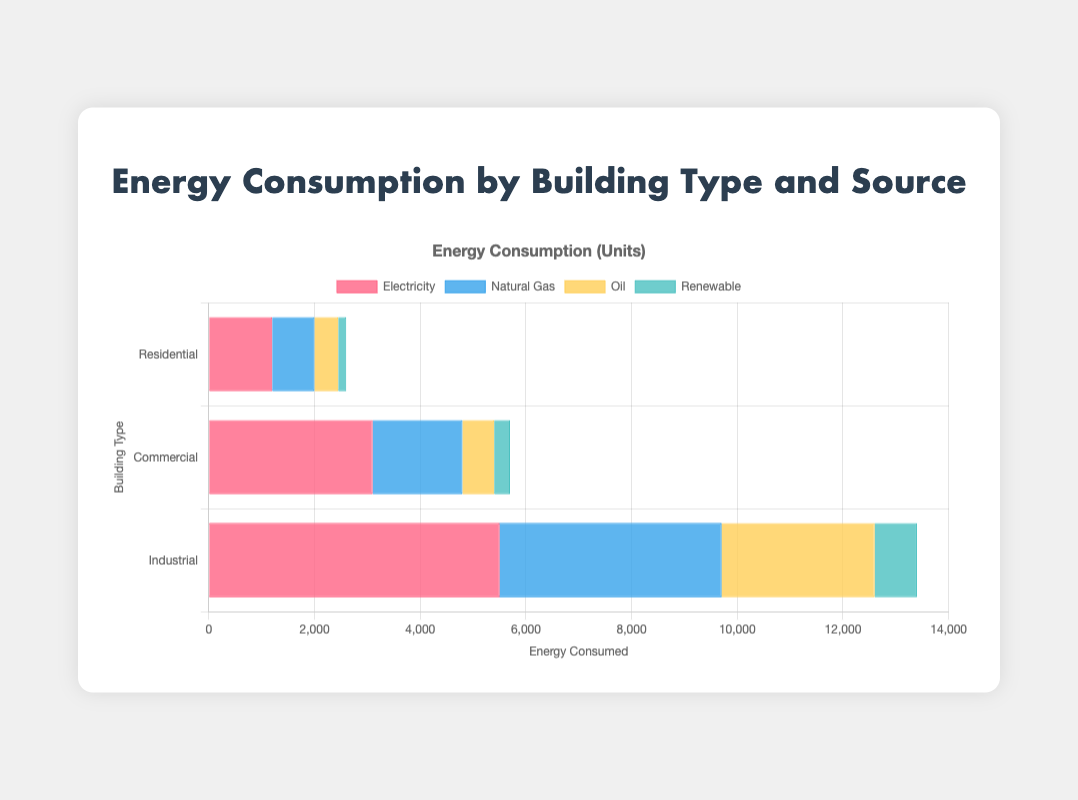Which building type consumes the most electricity? The Industrial building type has the tallest bar for electricity, indicating it consumes the most electricity.
Answer: Industrial Which source of energy contributes the least to the energy consumption of Residential buildings? The bar for Renewable energy in the Residential category is the shortest, indicating it contributes the least.
Answer: Renewable How much more electricity does the Commercial sector consume compared to the Residential sector? The Commercial sector consumes 3100 units of electricity, and the Residential sector consumes 1200 units. The difference is 3100 - 1200.
Answer: 1900 What is the total energy consumption for Natural Gas across all building types? Sum the energy consumption of Natural Gas for all building types: 800 (Residential) + 1700 (Commercial) + 4200 (Industrial) = 6700 units.
Answer: 6700 Compare the energy consumption of Oil between Commercial and Industrial buildings. Which one consumes more and by how much? The Commercial sector consumes 600 units of Oil, and the Industrial sector consumes 2900 units. The Industrial sector consumes more by 2900 - 600 = 2300 units.
Answer: Industrial, 2300 more Which building type has the highest total energy consumption, and what is the total? Sum up the energy consumption for all sources within each building type. The Industrial building type has the highest total: 5500 (Electricity) + 4200 (Natural Gas) + 2900 (Oil) + 800 (Renewable) = 13400 units.
Answer: Industrial, 13400 How does the Renewable energy consumption in the Industrial sector compare to the total Renewable energy consumption of all building types? The Industrial sector uses 800 units of Renewable energy. Sum all Renewable energy consumption: 150 (Residential) + 300 (Commercial) + 800 (Industrial) = 1250 units. The comparison is 800/1250.
Answer: Industrial consumes 64% of the total Renewable What is the average energy consumption per source in the Commercial sector? Sum the energy consumption for all sources in the Commercial sector and divide by the number of sources: (3100 + 1700 + 600 + 300) / 4.
Answer: 1700 units Is the Renewable energy consumption in the Residential sector more or less than half of the Oil consumption in the same sector? Half of the Oil consumption in the Residential sector is 450 / 2 = 225 units. The Renewable energy consumption is 150 units, which is less than 225 units.
Answer: Less 